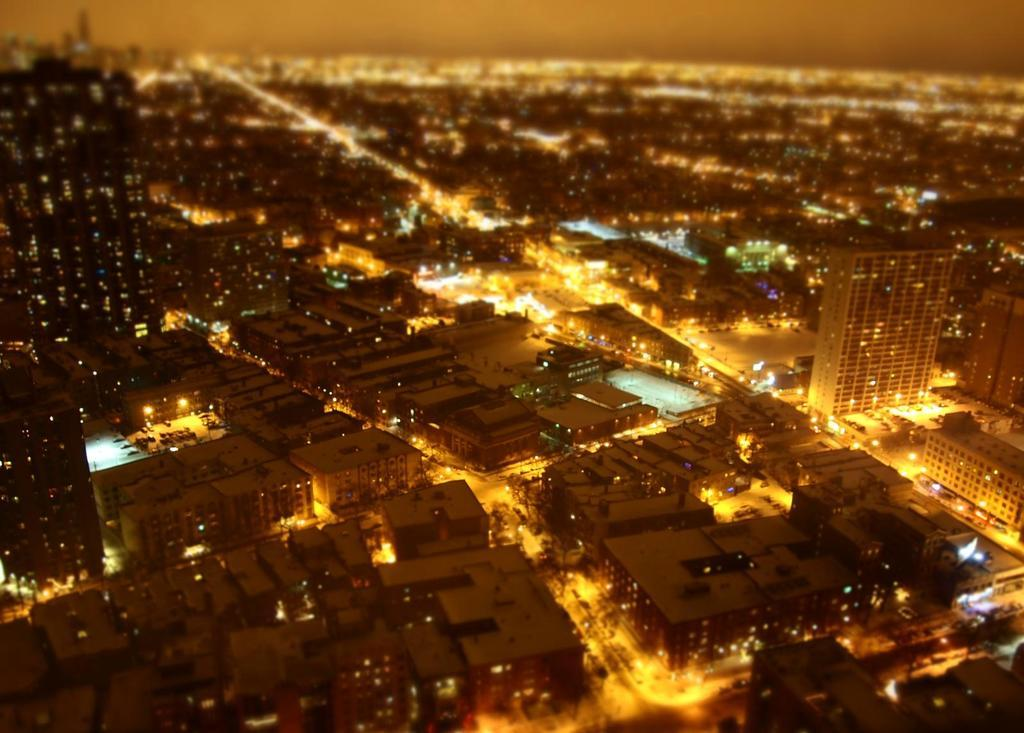What type of view is shown in the image? The image is an aerial view. What structures can be seen in the image? There are buildings in the image. What type of transportation infrastructure is visible? There are roads in the image. What type of objects are moving along the roads? There are vehicles in the image. What can be seen illuminating the roads and buildings? Lights are visible in the image. Can you see any fish swimming in the image? No, there are no fish visible in the image, as it features an aerial view of a city with buildings, roads, vehicles, and lights. 